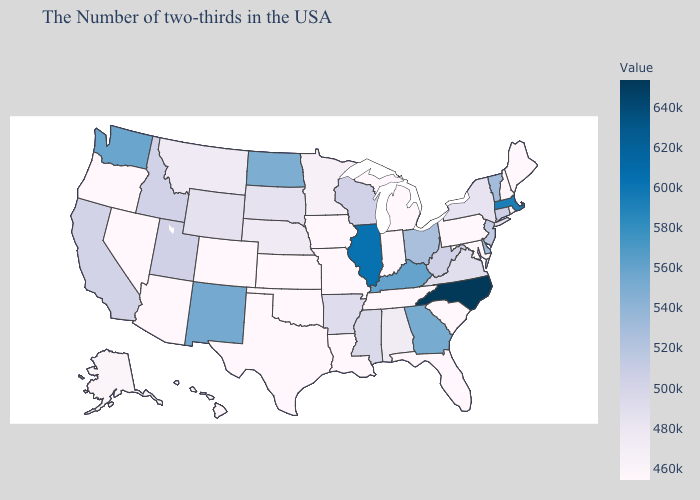Among the states that border Arkansas , does Mississippi have the lowest value?
Short answer required. No. Among the states that border New Jersey , does Pennsylvania have the highest value?
Answer briefly. No. Does Missouri have the highest value in the MidWest?
Write a very short answer. No. Does Delaware have the lowest value in the South?
Short answer required. No. Among the states that border South Carolina , does Georgia have the lowest value?
Be succinct. Yes. Among the states that border Connecticut , which have the lowest value?
Give a very brief answer. Rhode Island. Among the states that border Kentucky , which have the highest value?
Answer briefly. Illinois. Does North Carolina have the highest value in the USA?
Keep it brief. Yes. 